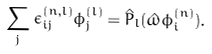Convert formula to latex. <formula><loc_0><loc_0><loc_500><loc_500>\sum _ { j } \epsilon ^ { ( n , l ) } _ { i j } \phi ^ { ( l ) } _ { j } = \hat { P } _ { l } ( \hat { \omega } \phi ^ { ( n ) } _ { i } ) .</formula> 